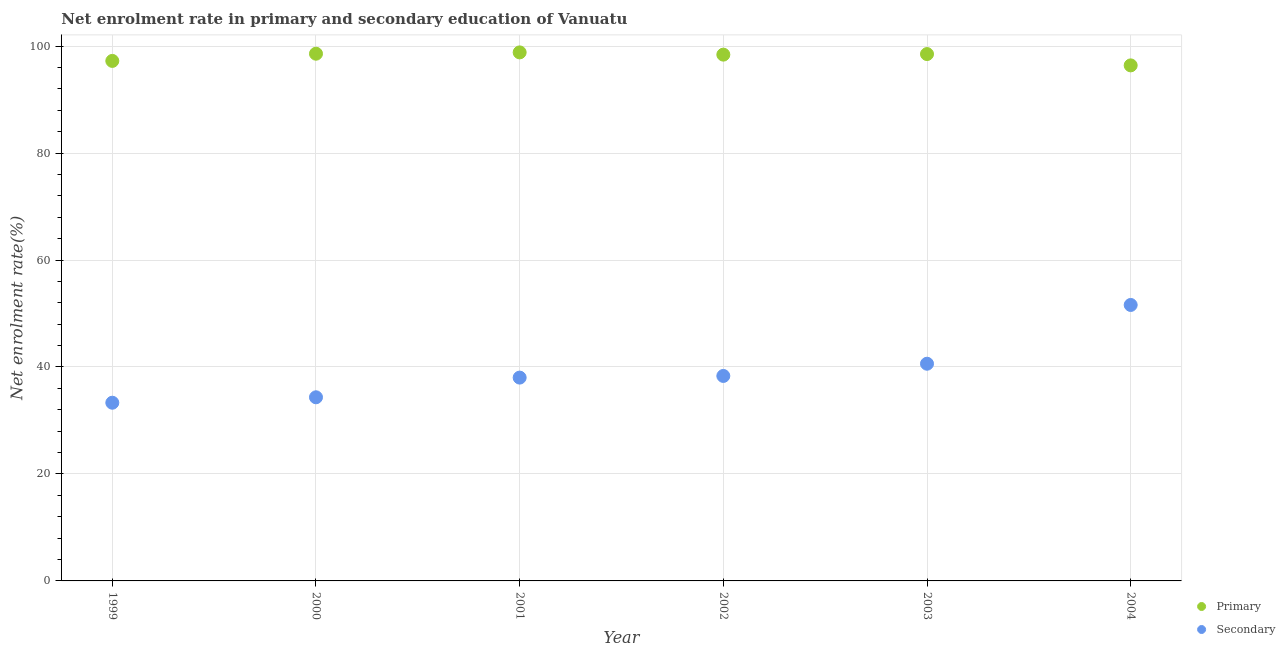Is the number of dotlines equal to the number of legend labels?
Your answer should be very brief. Yes. What is the enrollment rate in secondary education in 2000?
Give a very brief answer. 34.34. Across all years, what is the maximum enrollment rate in primary education?
Give a very brief answer. 98.83. Across all years, what is the minimum enrollment rate in primary education?
Your response must be concise. 96.4. In which year was the enrollment rate in secondary education maximum?
Offer a terse response. 2004. In which year was the enrollment rate in primary education minimum?
Keep it short and to the point. 2004. What is the total enrollment rate in secondary education in the graph?
Offer a terse response. 236.21. What is the difference between the enrollment rate in primary education in 1999 and that in 2000?
Your answer should be very brief. -1.35. What is the difference between the enrollment rate in secondary education in 2003 and the enrollment rate in primary education in 1999?
Offer a very short reply. -56.62. What is the average enrollment rate in secondary education per year?
Ensure brevity in your answer.  39.37. In the year 2000, what is the difference between the enrollment rate in secondary education and enrollment rate in primary education?
Ensure brevity in your answer.  -64.24. In how many years, is the enrollment rate in primary education greater than 92 %?
Ensure brevity in your answer.  6. What is the ratio of the enrollment rate in secondary education in 2000 to that in 2001?
Your answer should be very brief. 0.9. Is the enrollment rate in primary education in 1999 less than that in 2001?
Provide a succinct answer. Yes. Is the difference between the enrollment rate in primary education in 2000 and 2002 greater than the difference between the enrollment rate in secondary education in 2000 and 2002?
Ensure brevity in your answer.  Yes. What is the difference between the highest and the second highest enrollment rate in secondary education?
Give a very brief answer. 10.99. What is the difference between the highest and the lowest enrollment rate in primary education?
Your answer should be compact. 2.43. In how many years, is the enrollment rate in primary education greater than the average enrollment rate in primary education taken over all years?
Offer a very short reply. 4. Is the sum of the enrollment rate in primary education in 2000 and 2004 greater than the maximum enrollment rate in secondary education across all years?
Your answer should be very brief. Yes. Does the enrollment rate in secondary education monotonically increase over the years?
Ensure brevity in your answer.  Yes. How many dotlines are there?
Your answer should be very brief. 2. How many years are there in the graph?
Provide a short and direct response. 6. What is the difference between two consecutive major ticks on the Y-axis?
Your response must be concise. 20. Are the values on the major ticks of Y-axis written in scientific E-notation?
Your answer should be very brief. No. Where does the legend appear in the graph?
Your answer should be compact. Bottom right. How are the legend labels stacked?
Provide a short and direct response. Vertical. What is the title of the graph?
Ensure brevity in your answer.  Net enrolment rate in primary and secondary education of Vanuatu. Does "Pregnant women" appear as one of the legend labels in the graph?
Your answer should be very brief. No. What is the label or title of the Y-axis?
Keep it short and to the point. Net enrolment rate(%). What is the Net enrolment rate(%) in Primary in 1999?
Your answer should be very brief. 97.23. What is the Net enrolment rate(%) of Secondary in 1999?
Provide a short and direct response. 33.32. What is the Net enrolment rate(%) of Primary in 2000?
Provide a succinct answer. 98.58. What is the Net enrolment rate(%) in Secondary in 2000?
Keep it short and to the point. 34.34. What is the Net enrolment rate(%) of Primary in 2001?
Your response must be concise. 98.83. What is the Net enrolment rate(%) of Secondary in 2001?
Your response must be concise. 38.02. What is the Net enrolment rate(%) in Primary in 2002?
Keep it short and to the point. 98.41. What is the Net enrolment rate(%) in Secondary in 2002?
Ensure brevity in your answer.  38.33. What is the Net enrolment rate(%) in Primary in 2003?
Provide a short and direct response. 98.51. What is the Net enrolment rate(%) of Secondary in 2003?
Your response must be concise. 40.61. What is the Net enrolment rate(%) in Primary in 2004?
Offer a terse response. 96.4. What is the Net enrolment rate(%) of Secondary in 2004?
Make the answer very short. 51.6. Across all years, what is the maximum Net enrolment rate(%) in Primary?
Make the answer very short. 98.83. Across all years, what is the maximum Net enrolment rate(%) of Secondary?
Offer a terse response. 51.6. Across all years, what is the minimum Net enrolment rate(%) in Primary?
Make the answer very short. 96.4. Across all years, what is the minimum Net enrolment rate(%) in Secondary?
Provide a succinct answer. 33.32. What is the total Net enrolment rate(%) in Primary in the graph?
Make the answer very short. 587.96. What is the total Net enrolment rate(%) of Secondary in the graph?
Give a very brief answer. 236.21. What is the difference between the Net enrolment rate(%) of Primary in 1999 and that in 2000?
Provide a short and direct response. -1.35. What is the difference between the Net enrolment rate(%) in Secondary in 1999 and that in 2000?
Provide a short and direct response. -1.02. What is the difference between the Net enrolment rate(%) in Primary in 1999 and that in 2001?
Offer a very short reply. -1.59. What is the difference between the Net enrolment rate(%) in Secondary in 1999 and that in 2001?
Offer a very short reply. -4.7. What is the difference between the Net enrolment rate(%) of Primary in 1999 and that in 2002?
Make the answer very short. -1.17. What is the difference between the Net enrolment rate(%) in Secondary in 1999 and that in 2002?
Offer a very short reply. -5.01. What is the difference between the Net enrolment rate(%) of Primary in 1999 and that in 2003?
Make the answer very short. -1.28. What is the difference between the Net enrolment rate(%) of Secondary in 1999 and that in 2003?
Provide a succinct answer. -7.29. What is the difference between the Net enrolment rate(%) of Primary in 1999 and that in 2004?
Make the answer very short. 0.84. What is the difference between the Net enrolment rate(%) of Secondary in 1999 and that in 2004?
Make the answer very short. -18.28. What is the difference between the Net enrolment rate(%) of Primary in 2000 and that in 2001?
Make the answer very short. -0.25. What is the difference between the Net enrolment rate(%) of Secondary in 2000 and that in 2001?
Make the answer very short. -3.68. What is the difference between the Net enrolment rate(%) of Primary in 2000 and that in 2002?
Provide a short and direct response. 0.17. What is the difference between the Net enrolment rate(%) of Secondary in 2000 and that in 2002?
Ensure brevity in your answer.  -3.99. What is the difference between the Net enrolment rate(%) of Primary in 2000 and that in 2003?
Provide a short and direct response. 0.07. What is the difference between the Net enrolment rate(%) in Secondary in 2000 and that in 2003?
Make the answer very short. -6.28. What is the difference between the Net enrolment rate(%) in Primary in 2000 and that in 2004?
Give a very brief answer. 2.18. What is the difference between the Net enrolment rate(%) of Secondary in 2000 and that in 2004?
Ensure brevity in your answer.  -17.26. What is the difference between the Net enrolment rate(%) in Primary in 2001 and that in 2002?
Provide a short and direct response. 0.42. What is the difference between the Net enrolment rate(%) of Secondary in 2001 and that in 2002?
Keep it short and to the point. -0.31. What is the difference between the Net enrolment rate(%) in Primary in 2001 and that in 2003?
Offer a very short reply. 0.31. What is the difference between the Net enrolment rate(%) of Secondary in 2001 and that in 2003?
Your answer should be compact. -2.59. What is the difference between the Net enrolment rate(%) in Primary in 2001 and that in 2004?
Your answer should be compact. 2.43. What is the difference between the Net enrolment rate(%) in Secondary in 2001 and that in 2004?
Offer a terse response. -13.58. What is the difference between the Net enrolment rate(%) in Primary in 2002 and that in 2003?
Give a very brief answer. -0.11. What is the difference between the Net enrolment rate(%) in Secondary in 2002 and that in 2003?
Offer a very short reply. -2.28. What is the difference between the Net enrolment rate(%) in Primary in 2002 and that in 2004?
Make the answer very short. 2.01. What is the difference between the Net enrolment rate(%) of Secondary in 2002 and that in 2004?
Offer a terse response. -13.27. What is the difference between the Net enrolment rate(%) of Primary in 2003 and that in 2004?
Provide a short and direct response. 2.12. What is the difference between the Net enrolment rate(%) in Secondary in 2003 and that in 2004?
Provide a short and direct response. -10.99. What is the difference between the Net enrolment rate(%) of Primary in 1999 and the Net enrolment rate(%) of Secondary in 2000?
Keep it short and to the point. 62.9. What is the difference between the Net enrolment rate(%) in Primary in 1999 and the Net enrolment rate(%) in Secondary in 2001?
Provide a succinct answer. 59.22. What is the difference between the Net enrolment rate(%) of Primary in 1999 and the Net enrolment rate(%) of Secondary in 2002?
Offer a terse response. 58.91. What is the difference between the Net enrolment rate(%) of Primary in 1999 and the Net enrolment rate(%) of Secondary in 2003?
Offer a terse response. 56.62. What is the difference between the Net enrolment rate(%) in Primary in 1999 and the Net enrolment rate(%) in Secondary in 2004?
Provide a succinct answer. 45.63. What is the difference between the Net enrolment rate(%) in Primary in 2000 and the Net enrolment rate(%) in Secondary in 2001?
Give a very brief answer. 60.56. What is the difference between the Net enrolment rate(%) of Primary in 2000 and the Net enrolment rate(%) of Secondary in 2002?
Your response must be concise. 60.25. What is the difference between the Net enrolment rate(%) in Primary in 2000 and the Net enrolment rate(%) in Secondary in 2003?
Offer a terse response. 57.97. What is the difference between the Net enrolment rate(%) of Primary in 2000 and the Net enrolment rate(%) of Secondary in 2004?
Your answer should be very brief. 46.98. What is the difference between the Net enrolment rate(%) of Primary in 2001 and the Net enrolment rate(%) of Secondary in 2002?
Keep it short and to the point. 60.5. What is the difference between the Net enrolment rate(%) in Primary in 2001 and the Net enrolment rate(%) in Secondary in 2003?
Provide a succinct answer. 58.21. What is the difference between the Net enrolment rate(%) in Primary in 2001 and the Net enrolment rate(%) in Secondary in 2004?
Keep it short and to the point. 47.23. What is the difference between the Net enrolment rate(%) of Primary in 2002 and the Net enrolment rate(%) of Secondary in 2003?
Your answer should be very brief. 57.8. What is the difference between the Net enrolment rate(%) in Primary in 2002 and the Net enrolment rate(%) in Secondary in 2004?
Your answer should be very brief. 46.81. What is the difference between the Net enrolment rate(%) of Primary in 2003 and the Net enrolment rate(%) of Secondary in 2004?
Your answer should be compact. 46.91. What is the average Net enrolment rate(%) of Primary per year?
Your response must be concise. 97.99. What is the average Net enrolment rate(%) in Secondary per year?
Your answer should be compact. 39.37. In the year 1999, what is the difference between the Net enrolment rate(%) of Primary and Net enrolment rate(%) of Secondary?
Ensure brevity in your answer.  63.91. In the year 2000, what is the difference between the Net enrolment rate(%) of Primary and Net enrolment rate(%) of Secondary?
Offer a very short reply. 64.24. In the year 2001, what is the difference between the Net enrolment rate(%) of Primary and Net enrolment rate(%) of Secondary?
Give a very brief answer. 60.81. In the year 2002, what is the difference between the Net enrolment rate(%) of Primary and Net enrolment rate(%) of Secondary?
Make the answer very short. 60.08. In the year 2003, what is the difference between the Net enrolment rate(%) of Primary and Net enrolment rate(%) of Secondary?
Your answer should be very brief. 57.9. In the year 2004, what is the difference between the Net enrolment rate(%) of Primary and Net enrolment rate(%) of Secondary?
Offer a very short reply. 44.8. What is the ratio of the Net enrolment rate(%) of Primary in 1999 to that in 2000?
Provide a short and direct response. 0.99. What is the ratio of the Net enrolment rate(%) in Secondary in 1999 to that in 2000?
Keep it short and to the point. 0.97. What is the ratio of the Net enrolment rate(%) of Primary in 1999 to that in 2001?
Offer a very short reply. 0.98. What is the ratio of the Net enrolment rate(%) of Secondary in 1999 to that in 2001?
Your answer should be very brief. 0.88. What is the ratio of the Net enrolment rate(%) of Secondary in 1999 to that in 2002?
Your response must be concise. 0.87. What is the ratio of the Net enrolment rate(%) in Primary in 1999 to that in 2003?
Ensure brevity in your answer.  0.99. What is the ratio of the Net enrolment rate(%) in Secondary in 1999 to that in 2003?
Your answer should be very brief. 0.82. What is the ratio of the Net enrolment rate(%) of Primary in 1999 to that in 2004?
Your response must be concise. 1.01. What is the ratio of the Net enrolment rate(%) in Secondary in 1999 to that in 2004?
Provide a succinct answer. 0.65. What is the ratio of the Net enrolment rate(%) in Primary in 2000 to that in 2001?
Keep it short and to the point. 1. What is the ratio of the Net enrolment rate(%) in Secondary in 2000 to that in 2001?
Offer a very short reply. 0.9. What is the ratio of the Net enrolment rate(%) in Secondary in 2000 to that in 2002?
Ensure brevity in your answer.  0.9. What is the ratio of the Net enrolment rate(%) in Secondary in 2000 to that in 2003?
Keep it short and to the point. 0.85. What is the ratio of the Net enrolment rate(%) of Primary in 2000 to that in 2004?
Your answer should be compact. 1.02. What is the ratio of the Net enrolment rate(%) in Secondary in 2000 to that in 2004?
Keep it short and to the point. 0.67. What is the ratio of the Net enrolment rate(%) of Secondary in 2001 to that in 2003?
Keep it short and to the point. 0.94. What is the ratio of the Net enrolment rate(%) of Primary in 2001 to that in 2004?
Make the answer very short. 1.03. What is the ratio of the Net enrolment rate(%) in Secondary in 2001 to that in 2004?
Your response must be concise. 0.74. What is the ratio of the Net enrolment rate(%) of Secondary in 2002 to that in 2003?
Ensure brevity in your answer.  0.94. What is the ratio of the Net enrolment rate(%) in Primary in 2002 to that in 2004?
Your answer should be compact. 1.02. What is the ratio of the Net enrolment rate(%) of Secondary in 2002 to that in 2004?
Your response must be concise. 0.74. What is the ratio of the Net enrolment rate(%) of Primary in 2003 to that in 2004?
Offer a very short reply. 1.02. What is the ratio of the Net enrolment rate(%) in Secondary in 2003 to that in 2004?
Ensure brevity in your answer.  0.79. What is the difference between the highest and the second highest Net enrolment rate(%) in Primary?
Make the answer very short. 0.25. What is the difference between the highest and the second highest Net enrolment rate(%) in Secondary?
Provide a succinct answer. 10.99. What is the difference between the highest and the lowest Net enrolment rate(%) in Primary?
Keep it short and to the point. 2.43. What is the difference between the highest and the lowest Net enrolment rate(%) in Secondary?
Keep it short and to the point. 18.28. 